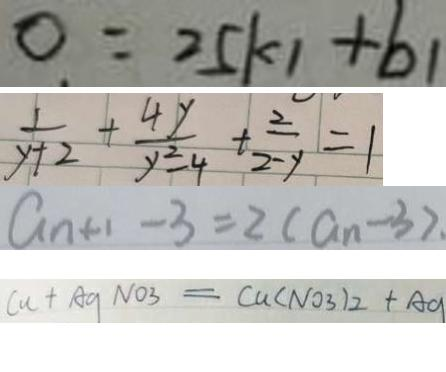<formula> <loc_0><loc_0><loc_500><loc_500>0 = 2 5 k _ { 1 } + b _ { 1 } 
 \frac { 1 } { y + 2 } + \frac { 4 y } { y ^ { 2 } - 4 } + \frac { 2 } { 2 - y } = 1 
 a _ { n + 1 } - 3 = 2 ( a _ { n } - 3 ) . 
 C u + A g N O _ { 3 } = C u ( N O _ { 3 } ) _ { 2 } + A g</formula> 